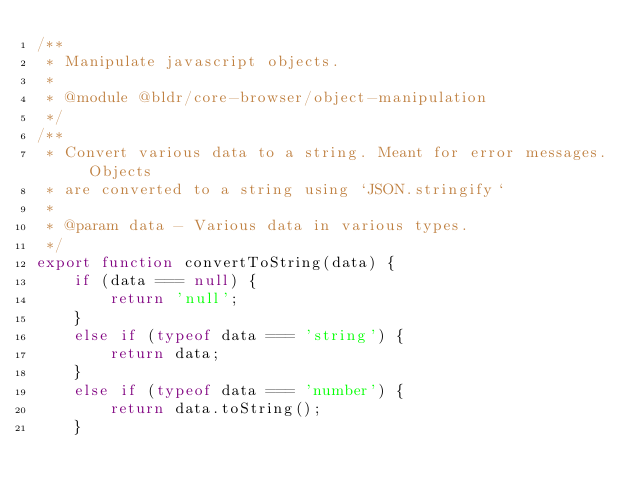<code> <loc_0><loc_0><loc_500><loc_500><_JavaScript_>/**
 * Manipulate javascript objects.
 *
 * @module @bldr/core-browser/object-manipulation
 */
/**
 * Convert various data to a string. Meant for error messages. Objects
 * are converted to a string using `JSON.stringify`
 *
 * @param data - Various data in various types.
 */
export function convertToString(data) {
    if (data === null) {
        return 'null';
    }
    else if (typeof data === 'string') {
        return data;
    }
    else if (typeof data === 'number') {
        return data.toString();
    }</code> 